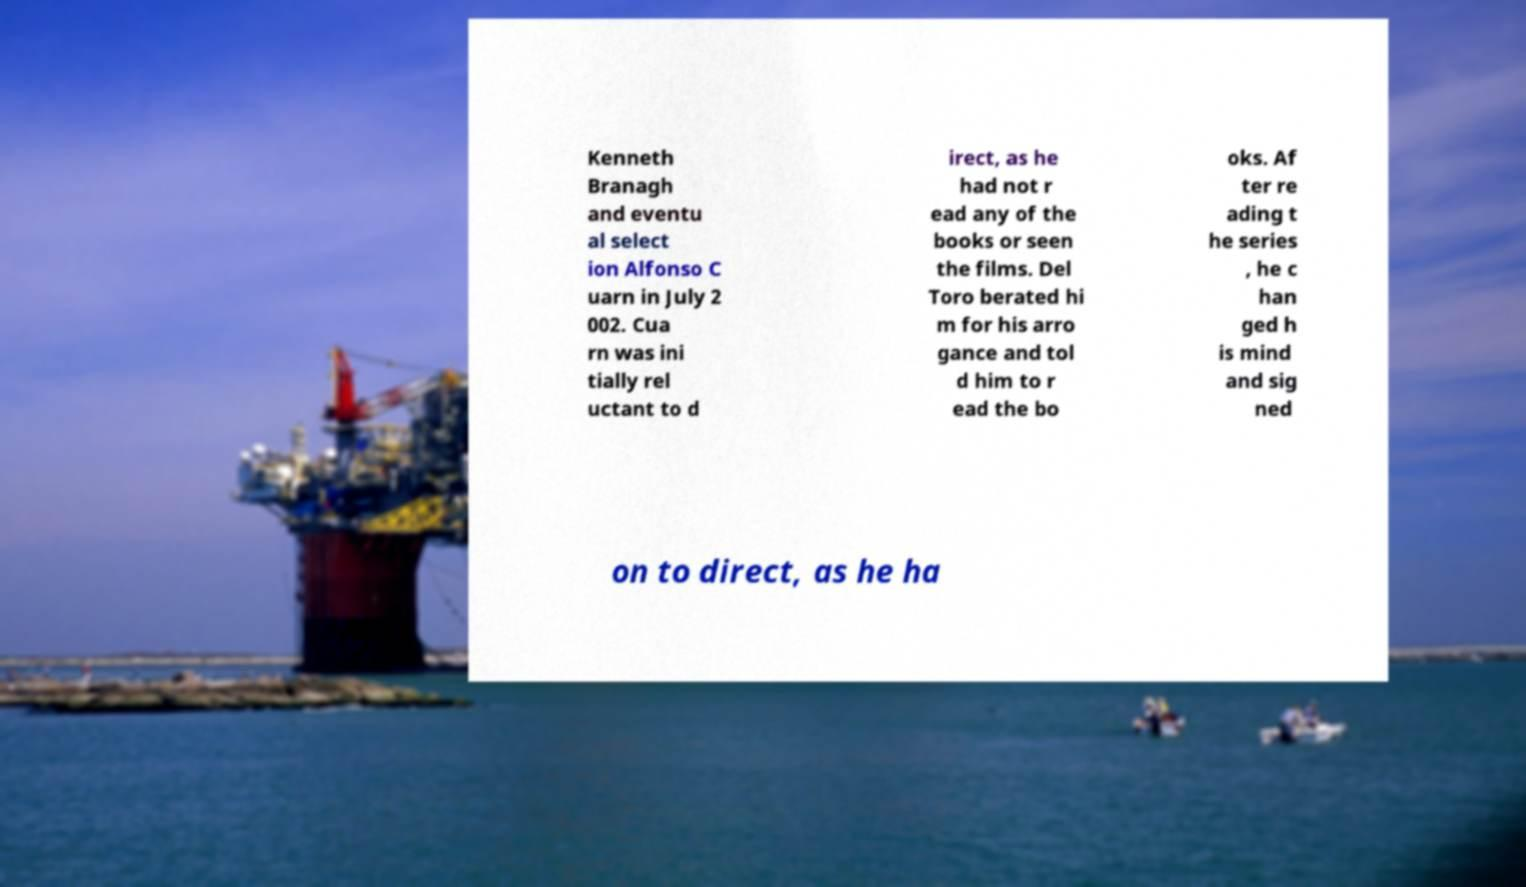There's text embedded in this image that I need extracted. Can you transcribe it verbatim? Kenneth Branagh and eventu al select ion Alfonso C uarn in July 2 002. Cua rn was ini tially rel uctant to d irect, as he had not r ead any of the books or seen the films. Del Toro berated hi m for his arro gance and tol d him to r ead the bo oks. Af ter re ading t he series , he c han ged h is mind and sig ned on to direct, as he ha 